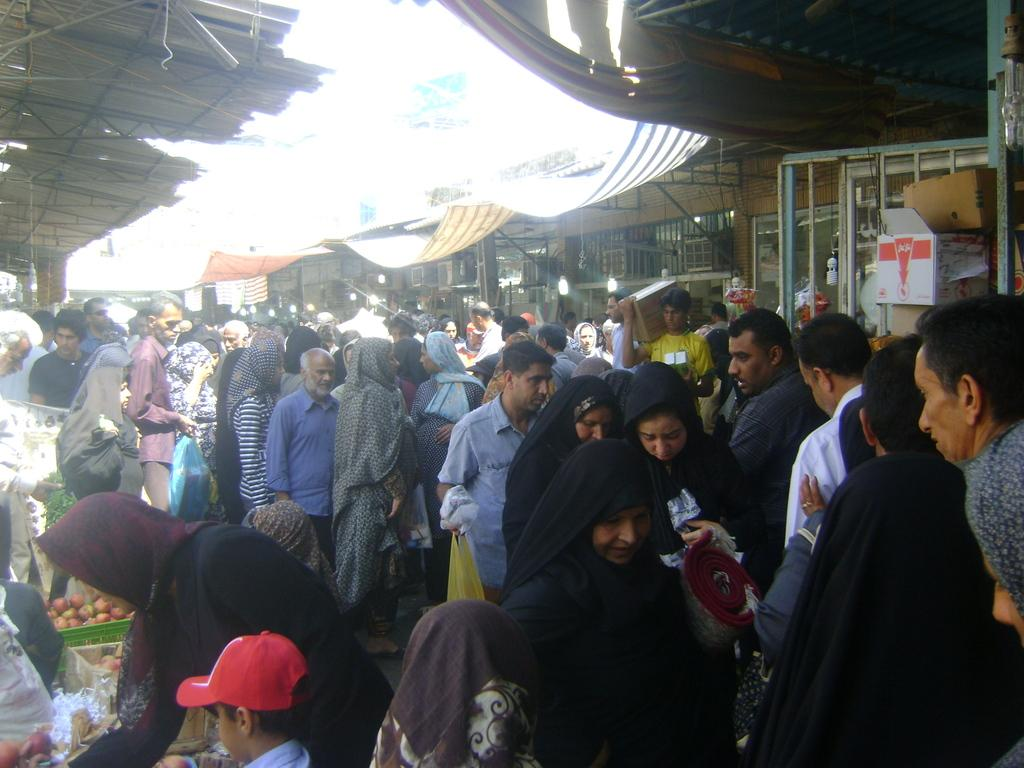How many people can be seen in the image? There are many people in the image. What type of location does the image appear to depict? The image appears to depict a vegetable market. What type of structure is visible at the top of the image? There is a shed visible at the top of the image. What type of wool can be seen being spun by a glove in the image? There is no wool or glove present in the image. How does the image change over time? The image itself does not change over time; it is a static representation of the scene. 